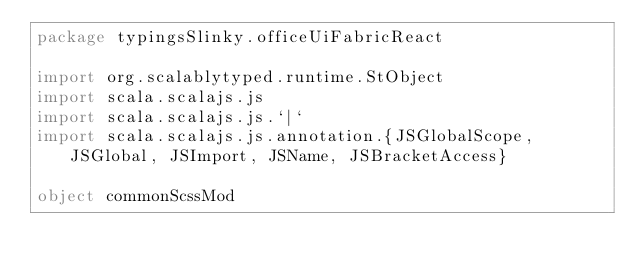<code> <loc_0><loc_0><loc_500><loc_500><_Scala_>package typingsSlinky.officeUiFabricReact

import org.scalablytyped.runtime.StObject
import scala.scalajs.js
import scala.scalajs.js.`|`
import scala.scalajs.js.annotation.{JSGlobalScope, JSGlobal, JSImport, JSName, JSBracketAccess}

object commonScssMod
</code> 